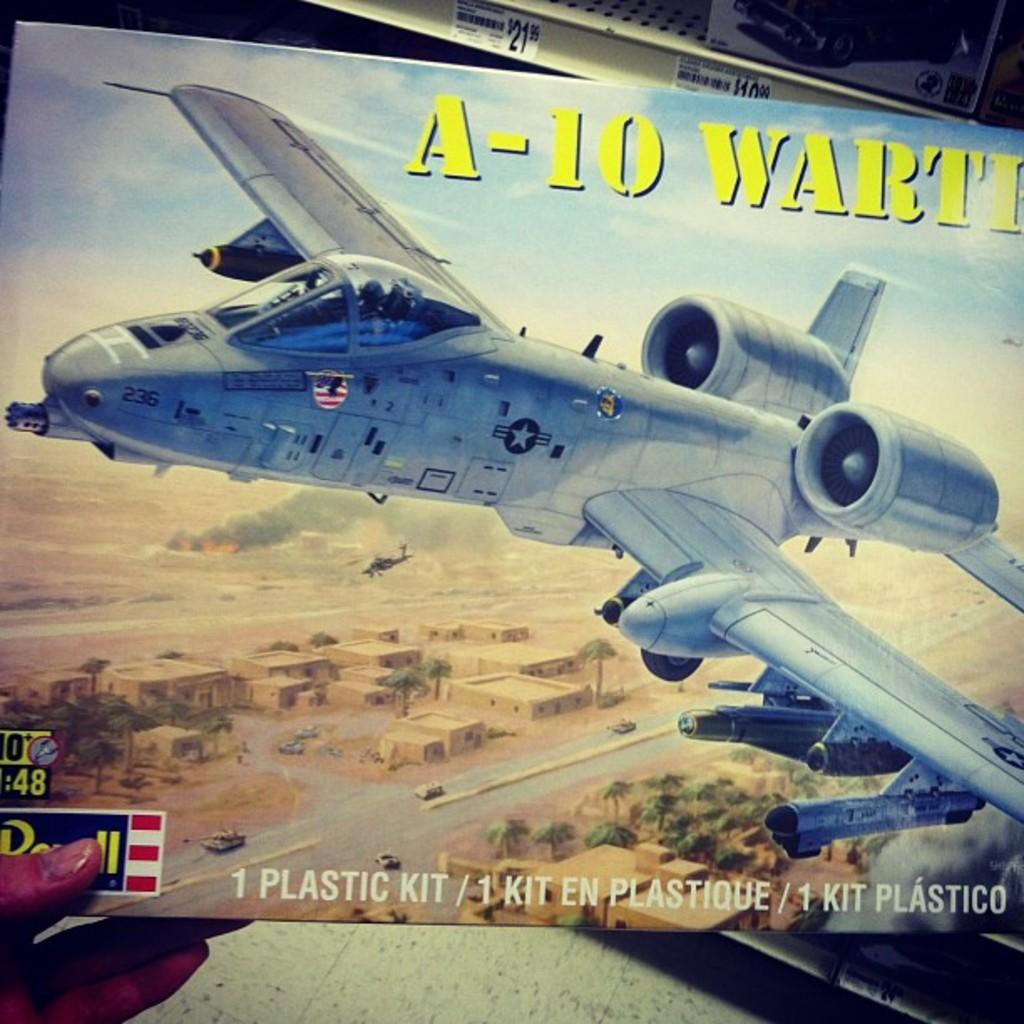<image>
Offer a succinct explanation of the picture presented. A box of  a plastic toy kit of A-10 is held up by the hand. 